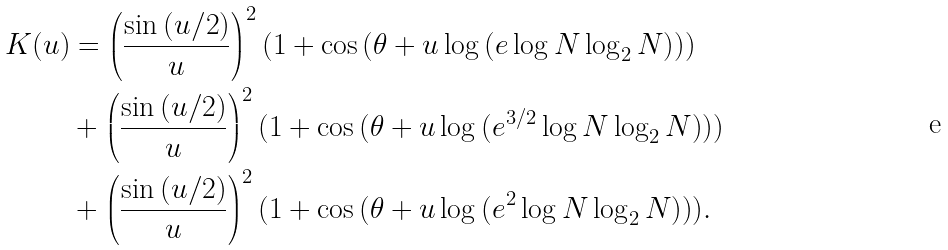Convert formula to latex. <formula><loc_0><loc_0><loc_500><loc_500>K ( u ) & = \left ( \frac { \sin { ( u / 2 ) } } { u } \right ) ^ { 2 } ( 1 + \cos { ( \theta + u \log { ( e \log { N } \log _ { 2 } { N } ) } ) } ) \\ & + \left ( \frac { \sin { ( u / 2 ) } } { u } \right ) ^ { 2 } ( 1 + \cos { ( \theta + u \log { ( e ^ { 3 / 2 } \log { N } \log _ { 2 } { N } ) } ) } ) \\ & + \left ( \frac { \sin { ( u / 2 ) } } { u } \right ) ^ { 2 } ( 1 + \cos { ( \theta + u \log { ( e ^ { 2 } \log { N } \log _ { 2 } { N } ) } ) } ) .</formula> 